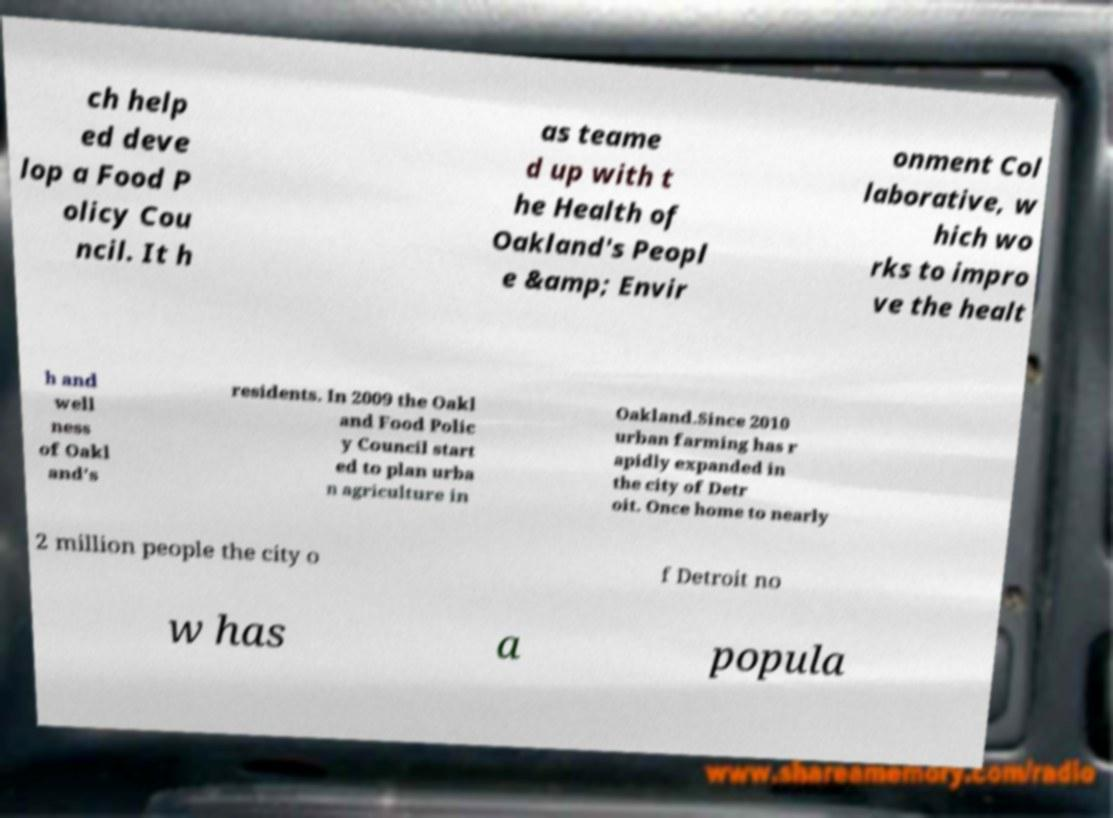Can you accurately transcribe the text from the provided image for me? ch help ed deve lop a Food P olicy Cou ncil. It h as teame d up with t he Health of Oakland's Peopl e &amp; Envir onment Col laborative, w hich wo rks to impro ve the healt h and well ness of Oakl and's residents. In 2009 the Oakl and Food Polic y Council start ed to plan urba n agriculture in Oakland.Since 2010 urban farming has r apidly expanded in the city of Detr oit. Once home to nearly 2 million people the city o f Detroit no w has a popula 